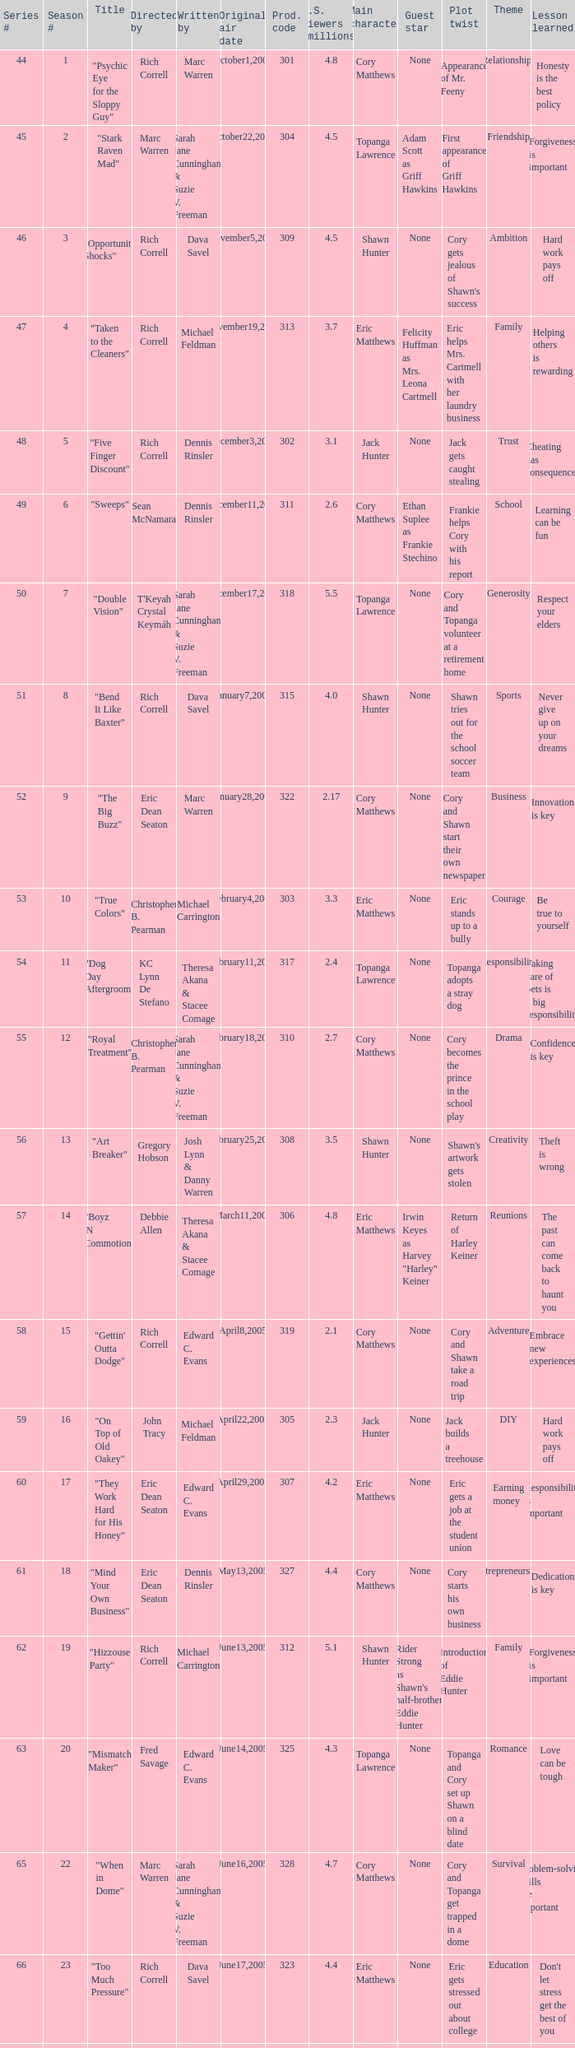What number episode of the season was titled "Vision Impossible"? 34.0. 